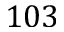<formula> <loc_0><loc_0><loc_500><loc_500>1 0 3</formula> 